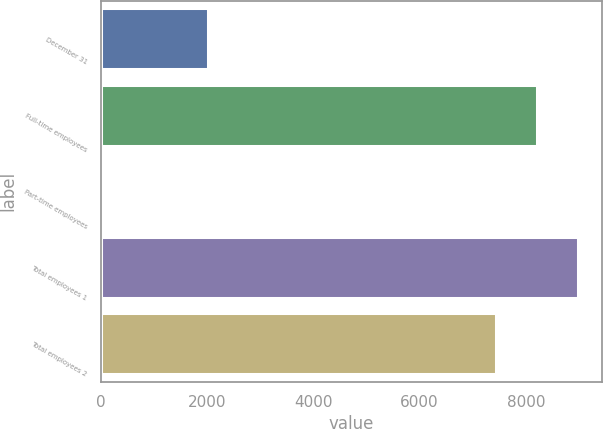<chart> <loc_0><loc_0><loc_500><loc_500><bar_chart><fcel>December 31<fcel>Full-time employees<fcel>Part-time employees<fcel>Total employees 1<fcel>Total employees 2<nl><fcel>2013<fcel>8208.6<fcel>45<fcel>8982.2<fcel>7435<nl></chart> 